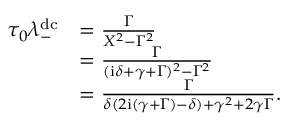Convert formula to latex. <formula><loc_0><loc_0><loc_500><loc_500>\begin{array} { r l } { \tau _ { 0 } \lambda _ { - } ^ { d c } } & { = \frac { \Gamma } { X ^ { 2 } - \Gamma ^ { 2 } } } \\ & { = \frac { \Gamma } { ( i \delta + \gamma + \Gamma ) ^ { 2 } - \Gamma ^ { 2 } } } \\ & { = \frac { \Gamma } { \delta ( 2 i ( \gamma + \Gamma ) - \delta ) + \gamma ^ { 2 } + 2 \gamma \Gamma } . } \end{array}</formula> 